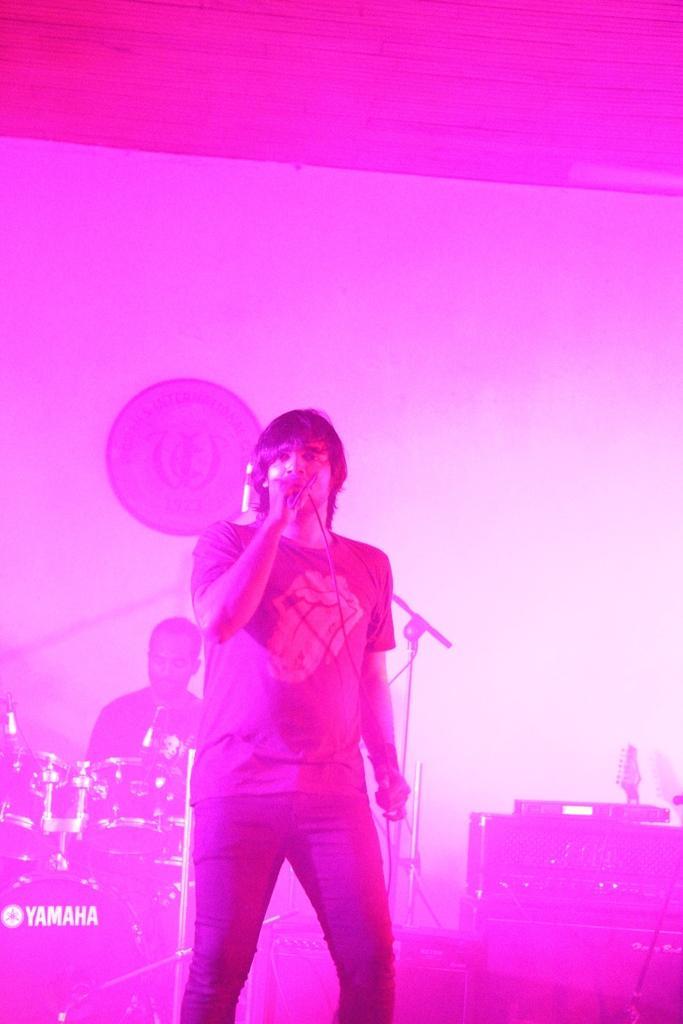In one or two sentences, can you explain what this image depicts? In this picture I can observe a man standing in the middle of the picture. He is holding a mic in his hand. Behind him I can observe another person playing drums. In the background I can observe wall. 